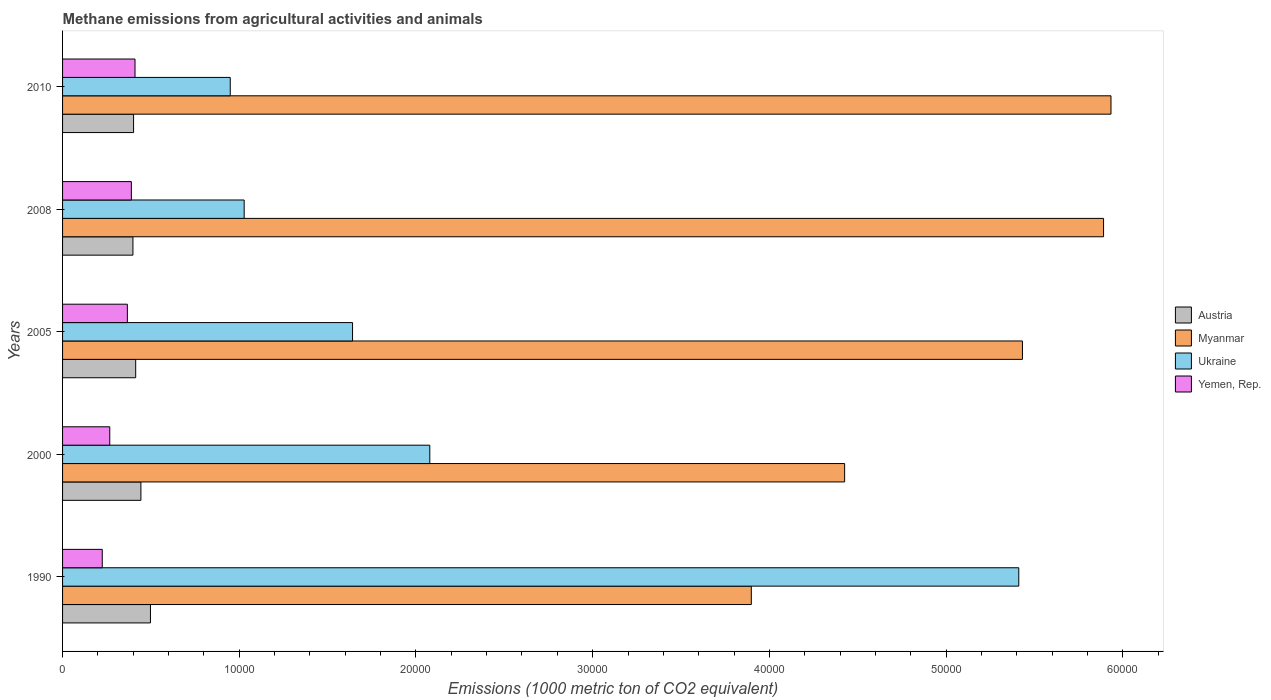Are the number of bars per tick equal to the number of legend labels?
Offer a very short reply. Yes. How many bars are there on the 3rd tick from the bottom?
Your answer should be compact. 4. What is the label of the 2nd group of bars from the top?
Your answer should be compact. 2008. What is the amount of methane emitted in Austria in 2010?
Your answer should be compact. 4018.8. Across all years, what is the maximum amount of methane emitted in Myanmar?
Ensure brevity in your answer.  5.93e+04. Across all years, what is the minimum amount of methane emitted in Austria?
Provide a short and direct response. 3982.8. In which year was the amount of methane emitted in Ukraine maximum?
Your answer should be very brief. 1990. What is the total amount of methane emitted in Ukraine in the graph?
Give a very brief answer. 1.11e+05. What is the difference between the amount of methane emitted in Ukraine in 1990 and that in 2008?
Ensure brevity in your answer.  4.38e+04. What is the difference between the amount of methane emitted in Ukraine in 1990 and the amount of methane emitted in Austria in 2008?
Offer a very short reply. 5.01e+04. What is the average amount of methane emitted in Yemen, Rep. per year?
Provide a short and direct response. 3315.54. In the year 2010, what is the difference between the amount of methane emitted in Yemen, Rep. and amount of methane emitted in Austria?
Provide a short and direct response. 81.1. In how many years, is the amount of methane emitted in Yemen, Rep. greater than 14000 1000 metric ton?
Make the answer very short. 0. What is the ratio of the amount of methane emitted in Yemen, Rep. in 1990 to that in 2000?
Ensure brevity in your answer.  0.84. Is the amount of methane emitted in Austria in 1990 less than that in 2010?
Your answer should be compact. No. Is the difference between the amount of methane emitted in Yemen, Rep. in 1990 and 2000 greater than the difference between the amount of methane emitted in Austria in 1990 and 2000?
Your answer should be compact. No. What is the difference between the highest and the second highest amount of methane emitted in Austria?
Ensure brevity in your answer.  539.9. What is the difference between the highest and the lowest amount of methane emitted in Myanmar?
Your answer should be compact. 2.04e+04. Is the sum of the amount of methane emitted in Yemen, Rep. in 2008 and 2010 greater than the maximum amount of methane emitted in Myanmar across all years?
Provide a succinct answer. No. What does the 1st bar from the top in 2010 represents?
Your answer should be very brief. Yemen, Rep. What does the 3rd bar from the bottom in 2000 represents?
Give a very brief answer. Ukraine. How many bars are there?
Keep it short and to the point. 20. Are all the bars in the graph horizontal?
Give a very brief answer. Yes. How many years are there in the graph?
Make the answer very short. 5. What is the difference between two consecutive major ticks on the X-axis?
Your response must be concise. 10000. Does the graph contain any zero values?
Your answer should be compact. No. Where does the legend appear in the graph?
Provide a succinct answer. Center right. How many legend labels are there?
Make the answer very short. 4. What is the title of the graph?
Make the answer very short. Methane emissions from agricultural activities and animals. Does "Haiti" appear as one of the legend labels in the graph?
Give a very brief answer. No. What is the label or title of the X-axis?
Provide a short and direct response. Emissions (1000 metric ton of CO2 equivalent). What is the Emissions (1000 metric ton of CO2 equivalent) of Austria in 1990?
Your answer should be very brief. 4973.8. What is the Emissions (1000 metric ton of CO2 equivalent) of Myanmar in 1990?
Offer a very short reply. 3.90e+04. What is the Emissions (1000 metric ton of CO2 equivalent) of Ukraine in 1990?
Offer a very short reply. 5.41e+04. What is the Emissions (1000 metric ton of CO2 equivalent) of Yemen, Rep. in 1990?
Offer a terse response. 2246.7. What is the Emissions (1000 metric ton of CO2 equivalent) of Austria in 2000?
Ensure brevity in your answer.  4433.9. What is the Emissions (1000 metric ton of CO2 equivalent) of Myanmar in 2000?
Offer a very short reply. 4.43e+04. What is the Emissions (1000 metric ton of CO2 equivalent) in Ukraine in 2000?
Make the answer very short. 2.08e+04. What is the Emissions (1000 metric ton of CO2 equivalent) of Yemen, Rep. in 2000?
Offer a terse response. 2671. What is the Emissions (1000 metric ton of CO2 equivalent) in Austria in 2005?
Your answer should be very brief. 4138.3. What is the Emissions (1000 metric ton of CO2 equivalent) in Myanmar in 2005?
Ensure brevity in your answer.  5.43e+04. What is the Emissions (1000 metric ton of CO2 equivalent) of Ukraine in 2005?
Your response must be concise. 1.64e+04. What is the Emissions (1000 metric ton of CO2 equivalent) in Yemen, Rep. in 2005?
Ensure brevity in your answer.  3666.5. What is the Emissions (1000 metric ton of CO2 equivalent) of Austria in 2008?
Your answer should be compact. 3982.8. What is the Emissions (1000 metric ton of CO2 equivalent) in Myanmar in 2008?
Provide a succinct answer. 5.89e+04. What is the Emissions (1000 metric ton of CO2 equivalent) in Ukraine in 2008?
Keep it short and to the point. 1.03e+04. What is the Emissions (1000 metric ton of CO2 equivalent) of Yemen, Rep. in 2008?
Give a very brief answer. 3893.6. What is the Emissions (1000 metric ton of CO2 equivalent) of Austria in 2010?
Offer a terse response. 4018.8. What is the Emissions (1000 metric ton of CO2 equivalent) in Myanmar in 2010?
Provide a short and direct response. 5.93e+04. What is the Emissions (1000 metric ton of CO2 equivalent) of Ukraine in 2010?
Give a very brief answer. 9489.8. What is the Emissions (1000 metric ton of CO2 equivalent) in Yemen, Rep. in 2010?
Provide a short and direct response. 4099.9. Across all years, what is the maximum Emissions (1000 metric ton of CO2 equivalent) of Austria?
Provide a short and direct response. 4973.8. Across all years, what is the maximum Emissions (1000 metric ton of CO2 equivalent) of Myanmar?
Offer a very short reply. 5.93e+04. Across all years, what is the maximum Emissions (1000 metric ton of CO2 equivalent) of Ukraine?
Provide a short and direct response. 5.41e+04. Across all years, what is the maximum Emissions (1000 metric ton of CO2 equivalent) in Yemen, Rep.?
Provide a succinct answer. 4099.9. Across all years, what is the minimum Emissions (1000 metric ton of CO2 equivalent) in Austria?
Offer a very short reply. 3982.8. Across all years, what is the minimum Emissions (1000 metric ton of CO2 equivalent) of Myanmar?
Your answer should be compact. 3.90e+04. Across all years, what is the minimum Emissions (1000 metric ton of CO2 equivalent) in Ukraine?
Offer a terse response. 9489.8. Across all years, what is the minimum Emissions (1000 metric ton of CO2 equivalent) in Yemen, Rep.?
Make the answer very short. 2246.7. What is the total Emissions (1000 metric ton of CO2 equivalent) in Austria in the graph?
Your answer should be very brief. 2.15e+04. What is the total Emissions (1000 metric ton of CO2 equivalent) in Myanmar in the graph?
Provide a succinct answer. 2.56e+05. What is the total Emissions (1000 metric ton of CO2 equivalent) in Ukraine in the graph?
Ensure brevity in your answer.  1.11e+05. What is the total Emissions (1000 metric ton of CO2 equivalent) of Yemen, Rep. in the graph?
Give a very brief answer. 1.66e+04. What is the difference between the Emissions (1000 metric ton of CO2 equivalent) in Austria in 1990 and that in 2000?
Provide a short and direct response. 539.9. What is the difference between the Emissions (1000 metric ton of CO2 equivalent) of Myanmar in 1990 and that in 2000?
Give a very brief answer. -5282. What is the difference between the Emissions (1000 metric ton of CO2 equivalent) of Ukraine in 1990 and that in 2000?
Provide a short and direct response. 3.33e+04. What is the difference between the Emissions (1000 metric ton of CO2 equivalent) of Yemen, Rep. in 1990 and that in 2000?
Offer a terse response. -424.3. What is the difference between the Emissions (1000 metric ton of CO2 equivalent) in Austria in 1990 and that in 2005?
Keep it short and to the point. 835.5. What is the difference between the Emissions (1000 metric ton of CO2 equivalent) of Myanmar in 1990 and that in 2005?
Provide a succinct answer. -1.53e+04. What is the difference between the Emissions (1000 metric ton of CO2 equivalent) in Ukraine in 1990 and that in 2005?
Offer a terse response. 3.77e+04. What is the difference between the Emissions (1000 metric ton of CO2 equivalent) of Yemen, Rep. in 1990 and that in 2005?
Ensure brevity in your answer.  -1419.8. What is the difference between the Emissions (1000 metric ton of CO2 equivalent) in Austria in 1990 and that in 2008?
Your answer should be compact. 991. What is the difference between the Emissions (1000 metric ton of CO2 equivalent) of Myanmar in 1990 and that in 2008?
Your response must be concise. -1.99e+04. What is the difference between the Emissions (1000 metric ton of CO2 equivalent) of Ukraine in 1990 and that in 2008?
Keep it short and to the point. 4.38e+04. What is the difference between the Emissions (1000 metric ton of CO2 equivalent) in Yemen, Rep. in 1990 and that in 2008?
Your response must be concise. -1646.9. What is the difference between the Emissions (1000 metric ton of CO2 equivalent) of Austria in 1990 and that in 2010?
Ensure brevity in your answer.  955. What is the difference between the Emissions (1000 metric ton of CO2 equivalent) of Myanmar in 1990 and that in 2010?
Your answer should be compact. -2.04e+04. What is the difference between the Emissions (1000 metric ton of CO2 equivalent) in Ukraine in 1990 and that in 2010?
Your response must be concise. 4.46e+04. What is the difference between the Emissions (1000 metric ton of CO2 equivalent) in Yemen, Rep. in 1990 and that in 2010?
Your answer should be compact. -1853.2. What is the difference between the Emissions (1000 metric ton of CO2 equivalent) of Austria in 2000 and that in 2005?
Keep it short and to the point. 295.6. What is the difference between the Emissions (1000 metric ton of CO2 equivalent) of Myanmar in 2000 and that in 2005?
Give a very brief answer. -1.01e+04. What is the difference between the Emissions (1000 metric ton of CO2 equivalent) in Ukraine in 2000 and that in 2005?
Your response must be concise. 4372.1. What is the difference between the Emissions (1000 metric ton of CO2 equivalent) in Yemen, Rep. in 2000 and that in 2005?
Your answer should be very brief. -995.5. What is the difference between the Emissions (1000 metric ton of CO2 equivalent) of Austria in 2000 and that in 2008?
Make the answer very short. 451.1. What is the difference between the Emissions (1000 metric ton of CO2 equivalent) in Myanmar in 2000 and that in 2008?
Provide a short and direct response. -1.47e+04. What is the difference between the Emissions (1000 metric ton of CO2 equivalent) in Ukraine in 2000 and that in 2008?
Offer a very short reply. 1.05e+04. What is the difference between the Emissions (1000 metric ton of CO2 equivalent) of Yemen, Rep. in 2000 and that in 2008?
Provide a short and direct response. -1222.6. What is the difference between the Emissions (1000 metric ton of CO2 equivalent) of Austria in 2000 and that in 2010?
Your response must be concise. 415.1. What is the difference between the Emissions (1000 metric ton of CO2 equivalent) of Myanmar in 2000 and that in 2010?
Offer a very short reply. -1.51e+04. What is the difference between the Emissions (1000 metric ton of CO2 equivalent) of Ukraine in 2000 and that in 2010?
Your answer should be compact. 1.13e+04. What is the difference between the Emissions (1000 metric ton of CO2 equivalent) of Yemen, Rep. in 2000 and that in 2010?
Make the answer very short. -1428.9. What is the difference between the Emissions (1000 metric ton of CO2 equivalent) of Austria in 2005 and that in 2008?
Provide a short and direct response. 155.5. What is the difference between the Emissions (1000 metric ton of CO2 equivalent) of Myanmar in 2005 and that in 2008?
Give a very brief answer. -4589.9. What is the difference between the Emissions (1000 metric ton of CO2 equivalent) of Ukraine in 2005 and that in 2008?
Ensure brevity in your answer.  6133.4. What is the difference between the Emissions (1000 metric ton of CO2 equivalent) in Yemen, Rep. in 2005 and that in 2008?
Your response must be concise. -227.1. What is the difference between the Emissions (1000 metric ton of CO2 equivalent) in Austria in 2005 and that in 2010?
Make the answer very short. 119.5. What is the difference between the Emissions (1000 metric ton of CO2 equivalent) of Myanmar in 2005 and that in 2010?
Provide a succinct answer. -5009.8. What is the difference between the Emissions (1000 metric ton of CO2 equivalent) in Ukraine in 2005 and that in 2010?
Your answer should be very brief. 6921.6. What is the difference between the Emissions (1000 metric ton of CO2 equivalent) in Yemen, Rep. in 2005 and that in 2010?
Make the answer very short. -433.4. What is the difference between the Emissions (1000 metric ton of CO2 equivalent) in Austria in 2008 and that in 2010?
Give a very brief answer. -36. What is the difference between the Emissions (1000 metric ton of CO2 equivalent) in Myanmar in 2008 and that in 2010?
Give a very brief answer. -419.9. What is the difference between the Emissions (1000 metric ton of CO2 equivalent) of Ukraine in 2008 and that in 2010?
Offer a very short reply. 788.2. What is the difference between the Emissions (1000 metric ton of CO2 equivalent) in Yemen, Rep. in 2008 and that in 2010?
Give a very brief answer. -206.3. What is the difference between the Emissions (1000 metric ton of CO2 equivalent) of Austria in 1990 and the Emissions (1000 metric ton of CO2 equivalent) of Myanmar in 2000?
Your answer should be compact. -3.93e+04. What is the difference between the Emissions (1000 metric ton of CO2 equivalent) in Austria in 1990 and the Emissions (1000 metric ton of CO2 equivalent) in Ukraine in 2000?
Offer a very short reply. -1.58e+04. What is the difference between the Emissions (1000 metric ton of CO2 equivalent) in Austria in 1990 and the Emissions (1000 metric ton of CO2 equivalent) in Yemen, Rep. in 2000?
Offer a terse response. 2302.8. What is the difference between the Emissions (1000 metric ton of CO2 equivalent) in Myanmar in 1990 and the Emissions (1000 metric ton of CO2 equivalent) in Ukraine in 2000?
Provide a short and direct response. 1.82e+04. What is the difference between the Emissions (1000 metric ton of CO2 equivalent) of Myanmar in 1990 and the Emissions (1000 metric ton of CO2 equivalent) of Yemen, Rep. in 2000?
Offer a very short reply. 3.63e+04. What is the difference between the Emissions (1000 metric ton of CO2 equivalent) in Ukraine in 1990 and the Emissions (1000 metric ton of CO2 equivalent) in Yemen, Rep. in 2000?
Offer a terse response. 5.14e+04. What is the difference between the Emissions (1000 metric ton of CO2 equivalent) in Austria in 1990 and the Emissions (1000 metric ton of CO2 equivalent) in Myanmar in 2005?
Offer a very short reply. -4.94e+04. What is the difference between the Emissions (1000 metric ton of CO2 equivalent) in Austria in 1990 and the Emissions (1000 metric ton of CO2 equivalent) in Ukraine in 2005?
Provide a short and direct response. -1.14e+04. What is the difference between the Emissions (1000 metric ton of CO2 equivalent) of Austria in 1990 and the Emissions (1000 metric ton of CO2 equivalent) of Yemen, Rep. in 2005?
Give a very brief answer. 1307.3. What is the difference between the Emissions (1000 metric ton of CO2 equivalent) of Myanmar in 1990 and the Emissions (1000 metric ton of CO2 equivalent) of Ukraine in 2005?
Your answer should be very brief. 2.26e+04. What is the difference between the Emissions (1000 metric ton of CO2 equivalent) in Myanmar in 1990 and the Emissions (1000 metric ton of CO2 equivalent) in Yemen, Rep. in 2005?
Your answer should be very brief. 3.53e+04. What is the difference between the Emissions (1000 metric ton of CO2 equivalent) of Ukraine in 1990 and the Emissions (1000 metric ton of CO2 equivalent) of Yemen, Rep. in 2005?
Give a very brief answer. 5.04e+04. What is the difference between the Emissions (1000 metric ton of CO2 equivalent) in Austria in 1990 and the Emissions (1000 metric ton of CO2 equivalent) in Myanmar in 2008?
Offer a terse response. -5.39e+04. What is the difference between the Emissions (1000 metric ton of CO2 equivalent) in Austria in 1990 and the Emissions (1000 metric ton of CO2 equivalent) in Ukraine in 2008?
Keep it short and to the point. -5304.2. What is the difference between the Emissions (1000 metric ton of CO2 equivalent) in Austria in 1990 and the Emissions (1000 metric ton of CO2 equivalent) in Yemen, Rep. in 2008?
Offer a terse response. 1080.2. What is the difference between the Emissions (1000 metric ton of CO2 equivalent) in Myanmar in 1990 and the Emissions (1000 metric ton of CO2 equivalent) in Ukraine in 2008?
Provide a short and direct response. 2.87e+04. What is the difference between the Emissions (1000 metric ton of CO2 equivalent) in Myanmar in 1990 and the Emissions (1000 metric ton of CO2 equivalent) in Yemen, Rep. in 2008?
Give a very brief answer. 3.51e+04. What is the difference between the Emissions (1000 metric ton of CO2 equivalent) in Ukraine in 1990 and the Emissions (1000 metric ton of CO2 equivalent) in Yemen, Rep. in 2008?
Make the answer very short. 5.02e+04. What is the difference between the Emissions (1000 metric ton of CO2 equivalent) of Austria in 1990 and the Emissions (1000 metric ton of CO2 equivalent) of Myanmar in 2010?
Ensure brevity in your answer.  -5.44e+04. What is the difference between the Emissions (1000 metric ton of CO2 equivalent) in Austria in 1990 and the Emissions (1000 metric ton of CO2 equivalent) in Ukraine in 2010?
Your answer should be compact. -4516. What is the difference between the Emissions (1000 metric ton of CO2 equivalent) of Austria in 1990 and the Emissions (1000 metric ton of CO2 equivalent) of Yemen, Rep. in 2010?
Give a very brief answer. 873.9. What is the difference between the Emissions (1000 metric ton of CO2 equivalent) in Myanmar in 1990 and the Emissions (1000 metric ton of CO2 equivalent) in Ukraine in 2010?
Your response must be concise. 2.95e+04. What is the difference between the Emissions (1000 metric ton of CO2 equivalent) of Myanmar in 1990 and the Emissions (1000 metric ton of CO2 equivalent) of Yemen, Rep. in 2010?
Your answer should be compact. 3.49e+04. What is the difference between the Emissions (1000 metric ton of CO2 equivalent) of Ukraine in 1990 and the Emissions (1000 metric ton of CO2 equivalent) of Yemen, Rep. in 2010?
Provide a succinct answer. 5.00e+04. What is the difference between the Emissions (1000 metric ton of CO2 equivalent) of Austria in 2000 and the Emissions (1000 metric ton of CO2 equivalent) of Myanmar in 2005?
Offer a very short reply. -4.99e+04. What is the difference between the Emissions (1000 metric ton of CO2 equivalent) of Austria in 2000 and the Emissions (1000 metric ton of CO2 equivalent) of Ukraine in 2005?
Provide a short and direct response. -1.20e+04. What is the difference between the Emissions (1000 metric ton of CO2 equivalent) in Austria in 2000 and the Emissions (1000 metric ton of CO2 equivalent) in Yemen, Rep. in 2005?
Your answer should be compact. 767.4. What is the difference between the Emissions (1000 metric ton of CO2 equivalent) in Myanmar in 2000 and the Emissions (1000 metric ton of CO2 equivalent) in Ukraine in 2005?
Keep it short and to the point. 2.78e+04. What is the difference between the Emissions (1000 metric ton of CO2 equivalent) of Myanmar in 2000 and the Emissions (1000 metric ton of CO2 equivalent) of Yemen, Rep. in 2005?
Offer a very short reply. 4.06e+04. What is the difference between the Emissions (1000 metric ton of CO2 equivalent) in Ukraine in 2000 and the Emissions (1000 metric ton of CO2 equivalent) in Yemen, Rep. in 2005?
Your response must be concise. 1.71e+04. What is the difference between the Emissions (1000 metric ton of CO2 equivalent) of Austria in 2000 and the Emissions (1000 metric ton of CO2 equivalent) of Myanmar in 2008?
Make the answer very short. -5.45e+04. What is the difference between the Emissions (1000 metric ton of CO2 equivalent) in Austria in 2000 and the Emissions (1000 metric ton of CO2 equivalent) in Ukraine in 2008?
Offer a very short reply. -5844.1. What is the difference between the Emissions (1000 metric ton of CO2 equivalent) of Austria in 2000 and the Emissions (1000 metric ton of CO2 equivalent) of Yemen, Rep. in 2008?
Your response must be concise. 540.3. What is the difference between the Emissions (1000 metric ton of CO2 equivalent) of Myanmar in 2000 and the Emissions (1000 metric ton of CO2 equivalent) of Ukraine in 2008?
Keep it short and to the point. 3.40e+04. What is the difference between the Emissions (1000 metric ton of CO2 equivalent) of Myanmar in 2000 and the Emissions (1000 metric ton of CO2 equivalent) of Yemen, Rep. in 2008?
Provide a short and direct response. 4.04e+04. What is the difference between the Emissions (1000 metric ton of CO2 equivalent) of Ukraine in 2000 and the Emissions (1000 metric ton of CO2 equivalent) of Yemen, Rep. in 2008?
Offer a very short reply. 1.69e+04. What is the difference between the Emissions (1000 metric ton of CO2 equivalent) of Austria in 2000 and the Emissions (1000 metric ton of CO2 equivalent) of Myanmar in 2010?
Keep it short and to the point. -5.49e+04. What is the difference between the Emissions (1000 metric ton of CO2 equivalent) of Austria in 2000 and the Emissions (1000 metric ton of CO2 equivalent) of Ukraine in 2010?
Offer a terse response. -5055.9. What is the difference between the Emissions (1000 metric ton of CO2 equivalent) of Austria in 2000 and the Emissions (1000 metric ton of CO2 equivalent) of Yemen, Rep. in 2010?
Your answer should be compact. 334. What is the difference between the Emissions (1000 metric ton of CO2 equivalent) of Myanmar in 2000 and the Emissions (1000 metric ton of CO2 equivalent) of Ukraine in 2010?
Ensure brevity in your answer.  3.48e+04. What is the difference between the Emissions (1000 metric ton of CO2 equivalent) of Myanmar in 2000 and the Emissions (1000 metric ton of CO2 equivalent) of Yemen, Rep. in 2010?
Make the answer very short. 4.02e+04. What is the difference between the Emissions (1000 metric ton of CO2 equivalent) of Ukraine in 2000 and the Emissions (1000 metric ton of CO2 equivalent) of Yemen, Rep. in 2010?
Make the answer very short. 1.67e+04. What is the difference between the Emissions (1000 metric ton of CO2 equivalent) of Austria in 2005 and the Emissions (1000 metric ton of CO2 equivalent) of Myanmar in 2008?
Your answer should be compact. -5.48e+04. What is the difference between the Emissions (1000 metric ton of CO2 equivalent) of Austria in 2005 and the Emissions (1000 metric ton of CO2 equivalent) of Ukraine in 2008?
Provide a succinct answer. -6139.7. What is the difference between the Emissions (1000 metric ton of CO2 equivalent) of Austria in 2005 and the Emissions (1000 metric ton of CO2 equivalent) of Yemen, Rep. in 2008?
Provide a succinct answer. 244.7. What is the difference between the Emissions (1000 metric ton of CO2 equivalent) in Myanmar in 2005 and the Emissions (1000 metric ton of CO2 equivalent) in Ukraine in 2008?
Keep it short and to the point. 4.40e+04. What is the difference between the Emissions (1000 metric ton of CO2 equivalent) of Myanmar in 2005 and the Emissions (1000 metric ton of CO2 equivalent) of Yemen, Rep. in 2008?
Give a very brief answer. 5.04e+04. What is the difference between the Emissions (1000 metric ton of CO2 equivalent) of Ukraine in 2005 and the Emissions (1000 metric ton of CO2 equivalent) of Yemen, Rep. in 2008?
Offer a terse response. 1.25e+04. What is the difference between the Emissions (1000 metric ton of CO2 equivalent) in Austria in 2005 and the Emissions (1000 metric ton of CO2 equivalent) in Myanmar in 2010?
Your response must be concise. -5.52e+04. What is the difference between the Emissions (1000 metric ton of CO2 equivalent) in Austria in 2005 and the Emissions (1000 metric ton of CO2 equivalent) in Ukraine in 2010?
Provide a succinct answer. -5351.5. What is the difference between the Emissions (1000 metric ton of CO2 equivalent) of Austria in 2005 and the Emissions (1000 metric ton of CO2 equivalent) of Yemen, Rep. in 2010?
Offer a very short reply. 38.4. What is the difference between the Emissions (1000 metric ton of CO2 equivalent) in Myanmar in 2005 and the Emissions (1000 metric ton of CO2 equivalent) in Ukraine in 2010?
Provide a short and direct response. 4.48e+04. What is the difference between the Emissions (1000 metric ton of CO2 equivalent) in Myanmar in 2005 and the Emissions (1000 metric ton of CO2 equivalent) in Yemen, Rep. in 2010?
Your answer should be compact. 5.02e+04. What is the difference between the Emissions (1000 metric ton of CO2 equivalent) in Ukraine in 2005 and the Emissions (1000 metric ton of CO2 equivalent) in Yemen, Rep. in 2010?
Make the answer very short. 1.23e+04. What is the difference between the Emissions (1000 metric ton of CO2 equivalent) of Austria in 2008 and the Emissions (1000 metric ton of CO2 equivalent) of Myanmar in 2010?
Your answer should be very brief. -5.54e+04. What is the difference between the Emissions (1000 metric ton of CO2 equivalent) of Austria in 2008 and the Emissions (1000 metric ton of CO2 equivalent) of Ukraine in 2010?
Provide a short and direct response. -5507. What is the difference between the Emissions (1000 metric ton of CO2 equivalent) in Austria in 2008 and the Emissions (1000 metric ton of CO2 equivalent) in Yemen, Rep. in 2010?
Your response must be concise. -117.1. What is the difference between the Emissions (1000 metric ton of CO2 equivalent) in Myanmar in 2008 and the Emissions (1000 metric ton of CO2 equivalent) in Ukraine in 2010?
Give a very brief answer. 4.94e+04. What is the difference between the Emissions (1000 metric ton of CO2 equivalent) in Myanmar in 2008 and the Emissions (1000 metric ton of CO2 equivalent) in Yemen, Rep. in 2010?
Your answer should be compact. 5.48e+04. What is the difference between the Emissions (1000 metric ton of CO2 equivalent) of Ukraine in 2008 and the Emissions (1000 metric ton of CO2 equivalent) of Yemen, Rep. in 2010?
Your answer should be compact. 6178.1. What is the average Emissions (1000 metric ton of CO2 equivalent) of Austria per year?
Give a very brief answer. 4309.52. What is the average Emissions (1000 metric ton of CO2 equivalent) in Myanmar per year?
Offer a terse response. 5.12e+04. What is the average Emissions (1000 metric ton of CO2 equivalent) in Ukraine per year?
Give a very brief answer. 2.22e+04. What is the average Emissions (1000 metric ton of CO2 equivalent) of Yemen, Rep. per year?
Your answer should be very brief. 3315.54. In the year 1990, what is the difference between the Emissions (1000 metric ton of CO2 equivalent) of Austria and Emissions (1000 metric ton of CO2 equivalent) of Myanmar?
Provide a short and direct response. -3.40e+04. In the year 1990, what is the difference between the Emissions (1000 metric ton of CO2 equivalent) in Austria and Emissions (1000 metric ton of CO2 equivalent) in Ukraine?
Ensure brevity in your answer.  -4.91e+04. In the year 1990, what is the difference between the Emissions (1000 metric ton of CO2 equivalent) of Austria and Emissions (1000 metric ton of CO2 equivalent) of Yemen, Rep.?
Offer a terse response. 2727.1. In the year 1990, what is the difference between the Emissions (1000 metric ton of CO2 equivalent) of Myanmar and Emissions (1000 metric ton of CO2 equivalent) of Ukraine?
Your answer should be very brief. -1.51e+04. In the year 1990, what is the difference between the Emissions (1000 metric ton of CO2 equivalent) of Myanmar and Emissions (1000 metric ton of CO2 equivalent) of Yemen, Rep.?
Your response must be concise. 3.67e+04. In the year 1990, what is the difference between the Emissions (1000 metric ton of CO2 equivalent) in Ukraine and Emissions (1000 metric ton of CO2 equivalent) in Yemen, Rep.?
Keep it short and to the point. 5.19e+04. In the year 2000, what is the difference between the Emissions (1000 metric ton of CO2 equivalent) in Austria and Emissions (1000 metric ton of CO2 equivalent) in Myanmar?
Provide a short and direct response. -3.98e+04. In the year 2000, what is the difference between the Emissions (1000 metric ton of CO2 equivalent) of Austria and Emissions (1000 metric ton of CO2 equivalent) of Ukraine?
Your answer should be compact. -1.63e+04. In the year 2000, what is the difference between the Emissions (1000 metric ton of CO2 equivalent) in Austria and Emissions (1000 metric ton of CO2 equivalent) in Yemen, Rep.?
Provide a succinct answer. 1762.9. In the year 2000, what is the difference between the Emissions (1000 metric ton of CO2 equivalent) of Myanmar and Emissions (1000 metric ton of CO2 equivalent) of Ukraine?
Provide a succinct answer. 2.35e+04. In the year 2000, what is the difference between the Emissions (1000 metric ton of CO2 equivalent) of Myanmar and Emissions (1000 metric ton of CO2 equivalent) of Yemen, Rep.?
Give a very brief answer. 4.16e+04. In the year 2000, what is the difference between the Emissions (1000 metric ton of CO2 equivalent) of Ukraine and Emissions (1000 metric ton of CO2 equivalent) of Yemen, Rep.?
Ensure brevity in your answer.  1.81e+04. In the year 2005, what is the difference between the Emissions (1000 metric ton of CO2 equivalent) in Austria and Emissions (1000 metric ton of CO2 equivalent) in Myanmar?
Provide a short and direct response. -5.02e+04. In the year 2005, what is the difference between the Emissions (1000 metric ton of CO2 equivalent) of Austria and Emissions (1000 metric ton of CO2 equivalent) of Ukraine?
Your answer should be compact. -1.23e+04. In the year 2005, what is the difference between the Emissions (1000 metric ton of CO2 equivalent) of Austria and Emissions (1000 metric ton of CO2 equivalent) of Yemen, Rep.?
Keep it short and to the point. 471.8. In the year 2005, what is the difference between the Emissions (1000 metric ton of CO2 equivalent) in Myanmar and Emissions (1000 metric ton of CO2 equivalent) in Ukraine?
Keep it short and to the point. 3.79e+04. In the year 2005, what is the difference between the Emissions (1000 metric ton of CO2 equivalent) of Myanmar and Emissions (1000 metric ton of CO2 equivalent) of Yemen, Rep.?
Your answer should be very brief. 5.07e+04. In the year 2005, what is the difference between the Emissions (1000 metric ton of CO2 equivalent) of Ukraine and Emissions (1000 metric ton of CO2 equivalent) of Yemen, Rep.?
Keep it short and to the point. 1.27e+04. In the year 2008, what is the difference between the Emissions (1000 metric ton of CO2 equivalent) in Austria and Emissions (1000 metric ton of CO2 equivalent) in Myanmar?
Make the answer very short. -5.49e+04. In the year 2008, what is the difference between the Emissions (1000 metric ton of CO2 equivalent) of Austria and Emissions (1000 metric ton of CO2 equivalent) of Ukraine?
Make the answer very short. -6295.2. In the year 2008, what is the difference between the Emissions (1000 metric ton of CO2 equivalent) of Austria and Emissions (1000 metric ton of CO2 equivalent) of Yemen, Rep.?
Make the answer very short. 89.2. In the year 2008, what is the difference between the Emissions (1000 metric ton of CO2 equivalent) of Myanmar and Emissions (1000 metric ton of CO2 equivalent) of Ukraine?
Make the answer very short. 4.86e+04. In the year 2008, what is the difference between the Emissions (1000 metric ton of CO2 equivalent) in Myanmar and Emissions (1000 metric ton of CO2 equivalent) in Yemen, Rep.?
Ensure brevity in your answer.  5.50e+04. In the year 2008, what is the difference between the Emissions (1000 metric ton of CO2 equivalent) of Ukraine and Emissions (1000 metric ton of CO2 equivalent) of Yemen, Rep.?
Ensure brevity in your answer.  6384.4. In the year 2010, what is the difference between the Emissions (1000 metric ton of CO2 equivalent) of Austria and Emissions (1000 metric ton of CO2 equivalent) of Myanmar?
Provide a short and direct response. -5.53e+04. In the year 2010, what is the difference between the Emissions (1000 metric ton of CO2 equivalent) of Austria and Emissions (1000 metric ton of CO2 equivalent) of Ukraine?
Provide a short and direct response. -5471. In the year 2010, what is the difference between the Emissions (1000 metric ton of CO2 equivalent) in Austria and Emissions (1000 metric ton of CO2 equivalent) in Yemen, Rep.?
Provide a succinct answer. -81.1. In the year 2010, what is the difference between the Emissions (1000 metric ton of CO2 equivalent) of Myanmar and Emissions (1000 metric ton of CO2 equivalent) of Ukraine?
Your response must be concise. 4.98e+04. In the year 2010, what is the difference between the Emissions (1000 metric ton of CO2 equivalent) in Myanmar and Emissions (1000 metric ton of CO2 equivalent) in Yemen, Rep.?
Offer a very short reply. 5.52e+04. In the year 2010, what is the difference between the Emissions (1000 metric ton of CO2 equivalent) in Ukraine and Emissions (1000 metric ton of CO2 equivalent) in Yemen, Rep.?
Give a very brief answer. 5389.9. What is the ratio of the Emissions (1000 metric ton of CO2 equivalent) in Austria in 1990 to that in 2000?
Keep it short and to the point. 1.12. What is the ratio of the Emissions (1000 metric ton of CO2 equivalent) of Myanmar in 1990 to that in 2000?
Provide a succinct answer. 0.88. What is the ratio of the Emissions (1000 metric ton of CO2 equivalent) of Ukraine in 1990 to that in 2000?
Provide a succinct answer. 2.6. What is the ratio of the Emissions (1000 metric ton of CO2 equivalent) of Yemen, Rep. in 1990 to that in 2000?
Provide a succinct answer. 0.84. What is the ratio of the Emissions (1000 metric ton of CO2 equivalent) of Austria in 1990 to that in 2005?
Ensure brevity in your answer.  1.2. What is the ratio of the Emissions (1000 metric ton of CO2 equivalent) of Myanmar in 1990 to that in 2005?
Make the answer very short. 0.72. What is the ratio of the Emissions (1000 metric ton of CO2 equivalent) in Ukraine in 1990 to that in 2005?
Give a very brief answer. 3.3. What is the ratio of the Emissions (1000 metric ton of CO2 equivalent) of Yemen, Rep. in 1990 to that in 2005?
Provide a succinct answer. 0.61. What is the ratio of the Emissions (1000 metric ton of CO2 equivalent) of Austria in 1990 to that in 2008?
Ensure brevity in your answer.  1.25. What is the ratio of the Emissions (1000 metric ton of CO2 equivalent) in Myanmar in 1990 to that in 2008?
Offer a very short reply. 0.66. What is the ratio of the Emissions (1000 metric ton of CO2 equivalent) in Ukraine in 1990 to that in 2008?
Give a very brief answer. 5.27. What is the ratio of the Emissions (1000 metric ton of CO2 equivalent) of Yemen, Rep. in 1990 to that in 2008?
Offer a very short reply. 0.58. What is the ratio of the Emissions (1000 metric ton of CO2 equivalent) of Austria in 1990 to that in 2010?
Provide a short and direct response. 1.24. What is the ratio of the Emissions (1000 metric ton of CO2 equivalent) in Myanmar in 1990 to that in 2010?
Ensure brevity in your answer.  0.66. What is the ratio of the Emissions (1000 metric ton of CO2 equivalent) in Ukraine in 1990 to that in 2010?
Provide a short and direct response. 5.7. What is the ratio of the Emissions (1000 metric ton of CO2 equivalent) in Yemen, Rep. in 1990 to that in 2010?
Make the answer very short. 0.55. What is the ratio of the Emissions (1000 metric ton of CO2 equivalent) in Austria in 2000 to that in 2005?
Offer a very short reply. 1.07. What is the ratio of the Emissions (1000 metric ton of CO2 equivalent) in Myanmar in 2000 to that in 2005?
Keep it short and to the point. 0.81. What is the ratio of the Emissions (1000 metric ton of CO2 equivalent) of Ukraine in 2000 to that in 2005?
Keep it short and to the point. 1.27. What is the ratio of the Emissions (1000 metric ton of CO2 equivalent) of Yemen, Rep. in 2000 to that in 2005?
Offer a very short reply. 0.73. What is the ratio of the Emissions (1000 metric ton of CO2 equivalent) of Austria in 2000 to that in 2008?
Give a very brief answer. 1.11. What is the ratio of the Emissions (1000 metric ton of CO2 equivalent) of Myanmar in 2000 to that in 2008?
Keep it short and to the point. 0.75. What is the ratio of the Emissions (1000 metric ton of CO2 equivalent) in Ukraine in 2000 to that in 2008?
Your response must be concise. 2.02. What is the ratio of the Emissions (1000 metric ton of CO2 equivalent) in Yemen, Rep. in 2000 to that in 2008?
Make the answer very short. 0.69. What is the ratio of the Emissions (1000 metric ton of CO2 equivalent) of Austria in 2000 to that in 2010?
Your response must be concise. 1.1. What is the ratio of the Emissions (1000 metric ton of CO2 equivalent) in Myanmar in 2000 to that in 2010?
Give a very brief answer. 0.75. What is the ratio of the Emissions (1000 metric ton of CO2 equivalent) in Ukraine in 2000 to that in 2010?
Your answer should be very brief. 2.19. What is the ratio of the Emissions (1000 metric ton of CO2 equivalent) of Yemen, Rep. in 2000 to that in 2010?
Your answer should be very brief. 0.65. What is the ratio of the Emissions (1000 metric ton of CO2 equivalent) of Austria in 2005 to that in 2008?
Keep it short and to the point. 1.04. What is the ratio of the Emissions (1000 metric ton of CO2 equivalent) of Myanmar in 2005 to that in 2008?
Your response must be concise. 0.92. What is the ratio of the Emissions (1000 metric ton of CO2 equivalent) of Ukraine in 2005 to that in 2008?
Keep it short and to the point. 1.6. What is the ratio of the Emissions (1000 metric ton of CO2 equivalent) in Yemen, Rep. in 2005 to that in 2008?
Provide a short and direct response. 0.94. What is the ratio of the Emissions (1000 metric ton of CO2 equivalent) of Austria in 2005 to that in 2010?
Your answer should be compact. 1.03. What is the ratio of the Emissions (1000 metric ton of CO2 equivalent) in Myanmar in 2005 to that in 2010?
Give a very brief answer. 0.92. What is the ratio of the Emissions (1000 metric ton of CO2 equivalent) of Ukraine in 2005 to that in 2010?
Ensure brevity in your answer.  1.73. What is the ratio of the Emissions (1000 metric ton of CO2 equivalent) in Yemen, Rep. in 2005 to that in 2010?
Provide a succinct answer. 0.89. What is the ratio of the Emissions (1000 metric ton of CO2 equivalent) in Myanmar in 2008 to that in 2010?
Ensure brevity in your answer.  0.99. What is the ratio of the Emissions (1000 metric ton of CO2 equivalent) in Ukraine in 2008 to that in 2010?
Keep it short and to the point. 1.08. What is the ratio of the Emissions (1000 metric ton of CO2 equivalent) in Yemen, Rep. in 2008 to that in 2010?
Provide a short and direct response. 0.95. What is the difference between the highest and the second highest Emissions (1000 metric ton of CO2 equivalent) in Austria?
Keep it short and to the point. 539.9. What is the difference between the highest and the second highest Emissions (1000 metric ton of CO2 equivalent) in Myanmar?
Give a very brief answer. 419.9. What is the difference between the highest and the second highest Emissions (1000 metric ton of CO2 equivalent) of Ukraine?
Offer a terse response. 3.33e+04. What is the difference between the highest and the second highest Emissions (1000 metric ton of CO2 equivalent) of Yemen, Rep.?
Keep it short and to the point. 206.3. What is the difference between the highest and the lowest Emissions (1000 metric ton of CO2 equivalent) of Austria?
Your response must be concise. 991. What is the difference between the highest and the lowest Emissions (1000 metric ton of CO2 equivalent) of Myanmar?
Provide a short and direct response. 2.04e+04. What is the difference between the highest and the lowest Emissions (1000 metric ton of CO2 equivalent) in Ukraine?
Offer a very short reply. 4.46e+04. What is the difference between the highest and the lowest Emissions (1000 metric ton of CO2 equivalent) in Yemen, Rep.?
Provide a succinct answer. 1853.2. 